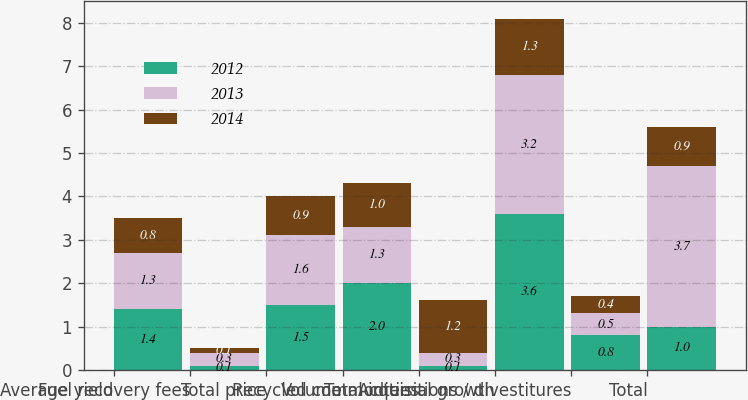Convert chart. <chart><loc_0><loc_0><loc_500><loc_500><stacked_bar_chart><ecel><fcel>Average yield<fcel>Fuel recovery fees<fcel>Total price<fcel>Volume<fcel>Recycled commodities<fcel>Total internal growth<fcel>Acquisitions / divestitures<fcel>Total<nl><fcel>2012<fcel>1.4<fcel>0.1<fcel>1.5<fcel>2<fcel>0.1<fcel>3.6<fcel>0.8<fcel>1<nl><fcel>2013<fcel>1.3<fcel>0.3<fcel>1.6<fcel>1.3<fcel>0.3<fcel>3.2<fcel>0.5<fcel>3.7<nl><fcel>2014<fcel>0.8<fcel>0.1<fcel>0.9<fcel>1<fcel>1.2<fcel>1.3<fcel>0.4<fcel>0.9<nl></chart> 